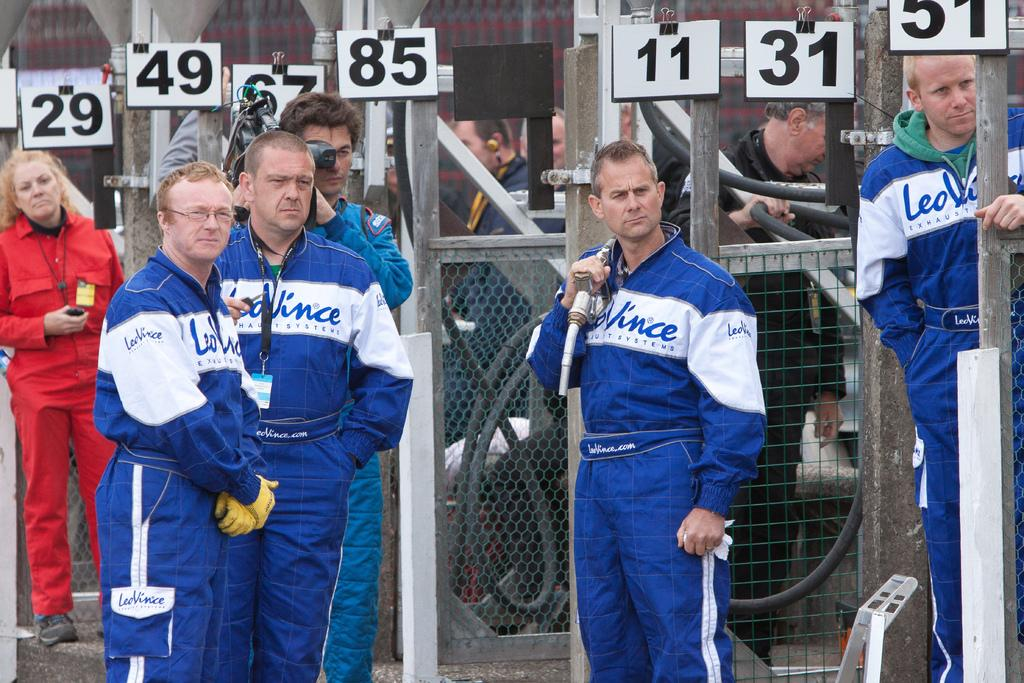Provide a one-sentence caption for the provided image. A group of men wearing matching Leo Vinice jumpsuits stand waiting. 